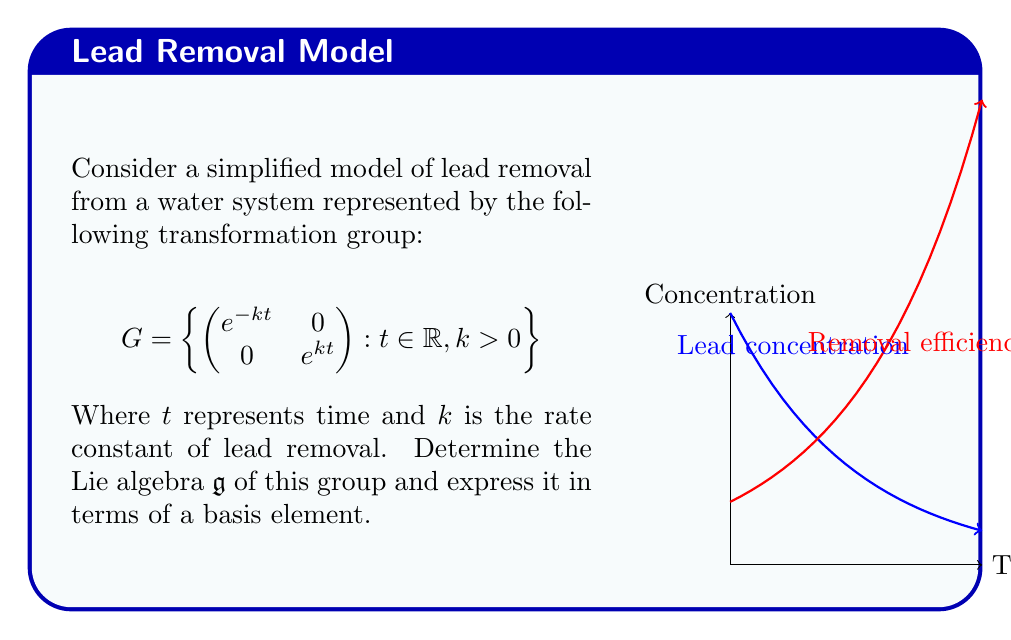Solve this math problem. To find the Lie algebra of this transformation group, we follow these steps:

1) The Lie algebra $\mathfrak{g}$ consists of the tangent space at the identity of the group. We can find this by differentiating the group elements with respect to $t$ at $t=0$.

2) Let's define a curve in the group:

   $$\gamma(t) = \begin{pmatrix} e^{-kt} & 0 \\ 0 & e^{kt} \end{pmatrix}$$

3) The tangent vector at the identity (t=0) is:

   $$\frac{d}{dt}\gamma(t)\bigg|_{t=0} = \frac{d}{dt}\begin{pmatrix} e^{-kt} & 0 \\ 0 & e^{kt} \end{pmatrix}\bigg|_{t=0}$$

4) Calculating the derivative:

   $$\frac{d}{dt}\gamma(t)\bigg|_{t=0} = \begin{pmatrix} -ke^{-kt} & 0 \\ 0 & ke^{kt} \end{pmatrix}\bigg|_{t=0} = \begin{pmatrix} -k & 0 \\ 0 & k \end{pmatrix}$$

5) This matrix forms a basis for the Lie algebra $\mathfrak{g}$. We can express it as:

   $$\mathfrak{g} = \left\{ \begin{pmatrix} -k & 0 \\ 0 & k \end{pmatrix} : k \in \mathbb{R} \right\}$$

6) To express this in terms of a single basis element, we can factor out $k$:

   $$\mathfrak{g} = \left\{ k\begin{pmatrix} -1 & 0 \\ 0 & 1 \end{pmatrix} : k \in \mathbb{R} \right\}$$

Therefore, the Lie algebra $\mathfrak{g}$ is one-dimensional, spanned by the basis element $\begin{pmatrix} -1 & 0 \\ 0 & 1 \end{pmatrix}$.
Answer: $\mathfrak{g} = \text{span}\left\{\begin{pmatrix} -1 & 0 \\ 0 & 1 \end{pmatrix}\right\}$ 